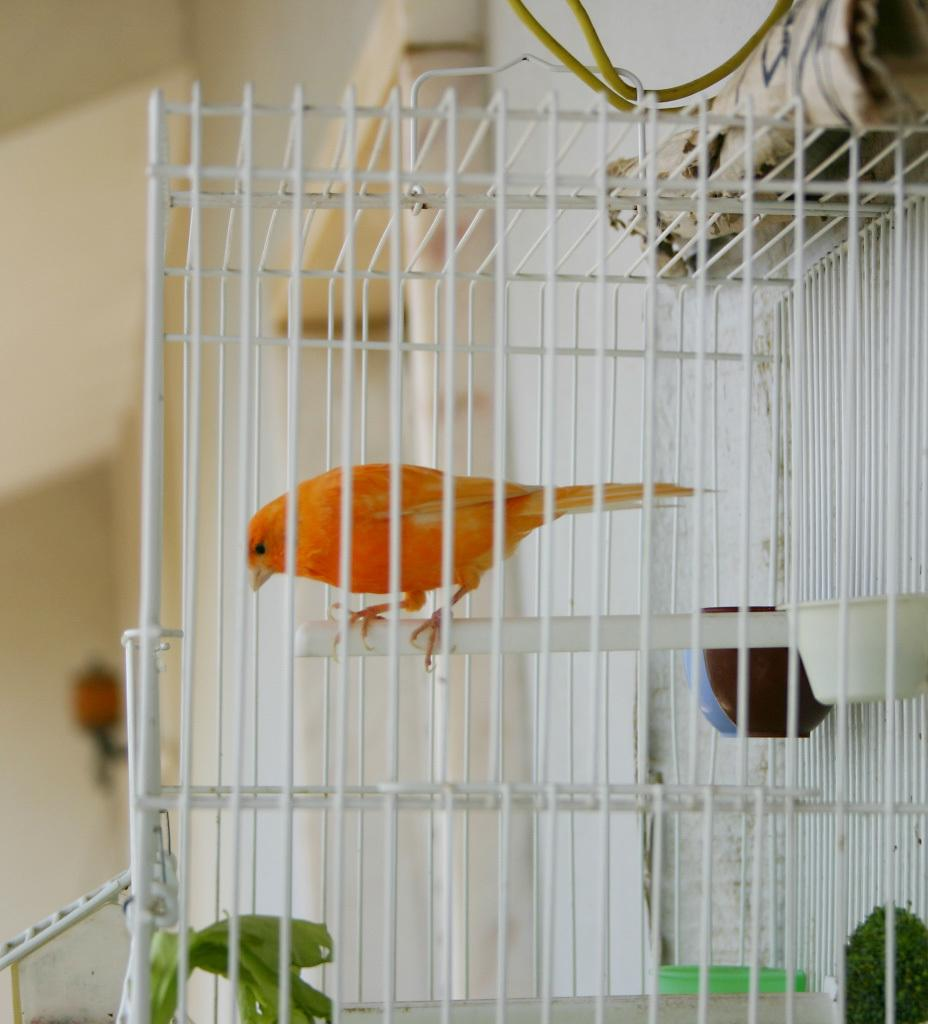What type of animal is in the image? There is a bird in the image. Where is the bird located? The bird is in a cage. What can be found inside the cage with the bird? There are bowls attached to metal rods in the cage. What is visible in the background of the image? There is a wall in the background of the image, and a lamp is attached to the wall. What type of jewel is hanging from the bird's cage in the image? There is no jewel hanging from the bird's cage in the image. 